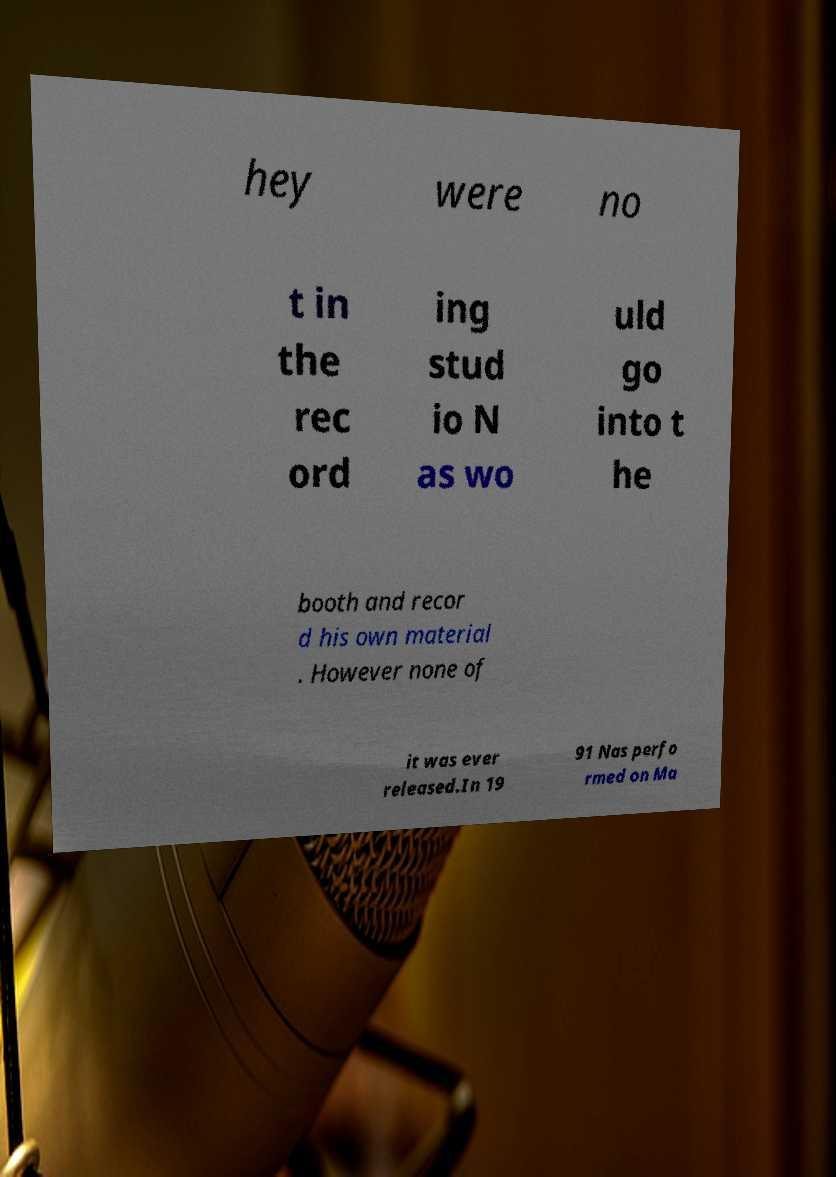For documentation purposes, I need the text within this image transcribed. Could you provide that? hey were no t in the rec ord ing stud io N as wo uld go into t he booth and recor d his own material . However none of it was ever released.In 19 91 Nas perfo rmed on Ma 